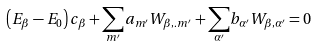Convert formula to latex. <formula><loc_0><loc_0><loc_500><loc_500>\left ( E _ { \beta } - E _ { 0 } \right ) c _ { \beta } + { \sum _ { m ^ { \prime } } } a _ { m ^ { \prime } } W _ { \beta , . m ^ { \prime } } + { \sum _ { \alpha ^ { \prime } } } b _ { \alpha ^ { \prime } } W _ { \beta , \alpha ^ { \prime } } = 0</formula> 